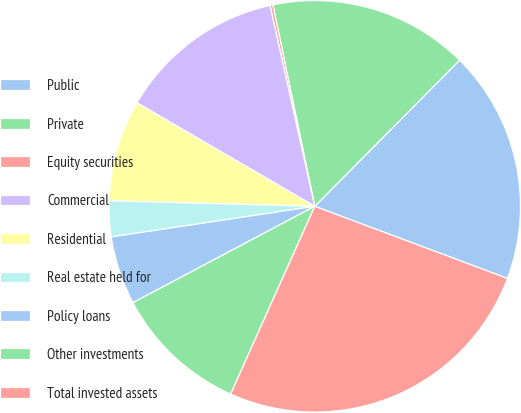Convert chart to OTSL. <chart><loc_0><loc_0><loc_500><loc_500><pie_chart><fcel>Public<fcel>Private<fcel>Equity securities<fcel>Commercial<fcel>Residential<fcel>Real estate held for<fcel>Policy loans<fcel>Other investments<fcel>Total invested assets<nl><fcel>18.27%<fcel>15.69%<fcel>0.23%<fcel>13.12%<fcel>7.96%<fcel>2.81%<fcel>5.38%<fcel>10.54%<fcel>26.0%<nl></chart> 